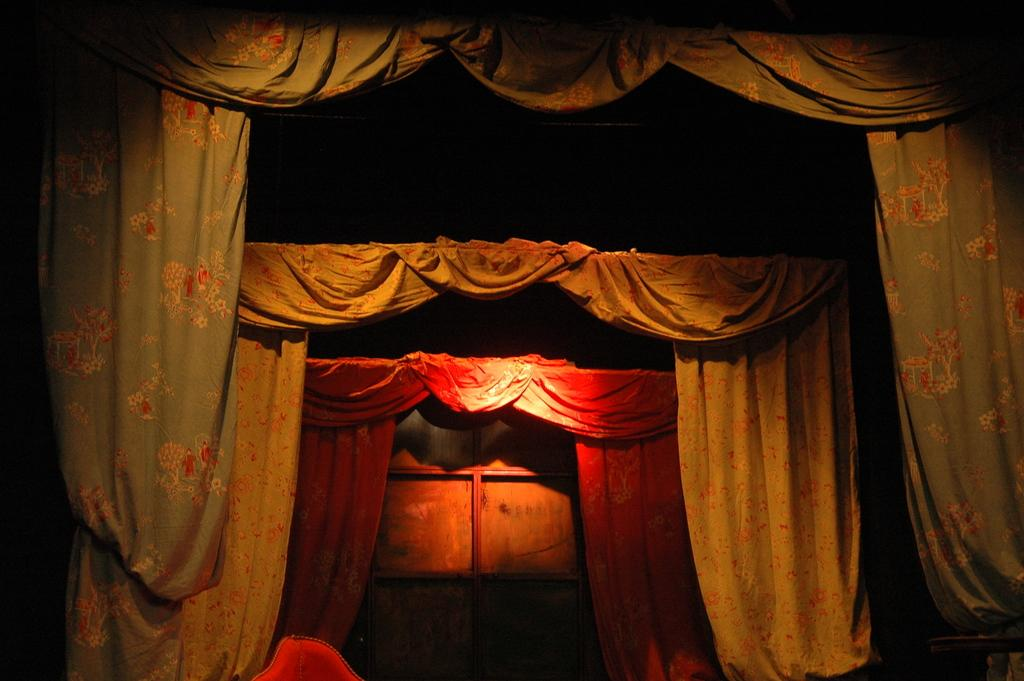What type of window treatment is present in the image? There are curtains in the image. What colors are the curtains in the image? The curtains are in red, cream, and green colors. Can you describe any visual effects in the image? There is a reflection of light visible in the image. What type of shock can be seen happening to the curtains in the image? There is no shock present in the image; the curtains are simply hanging in their positions. 